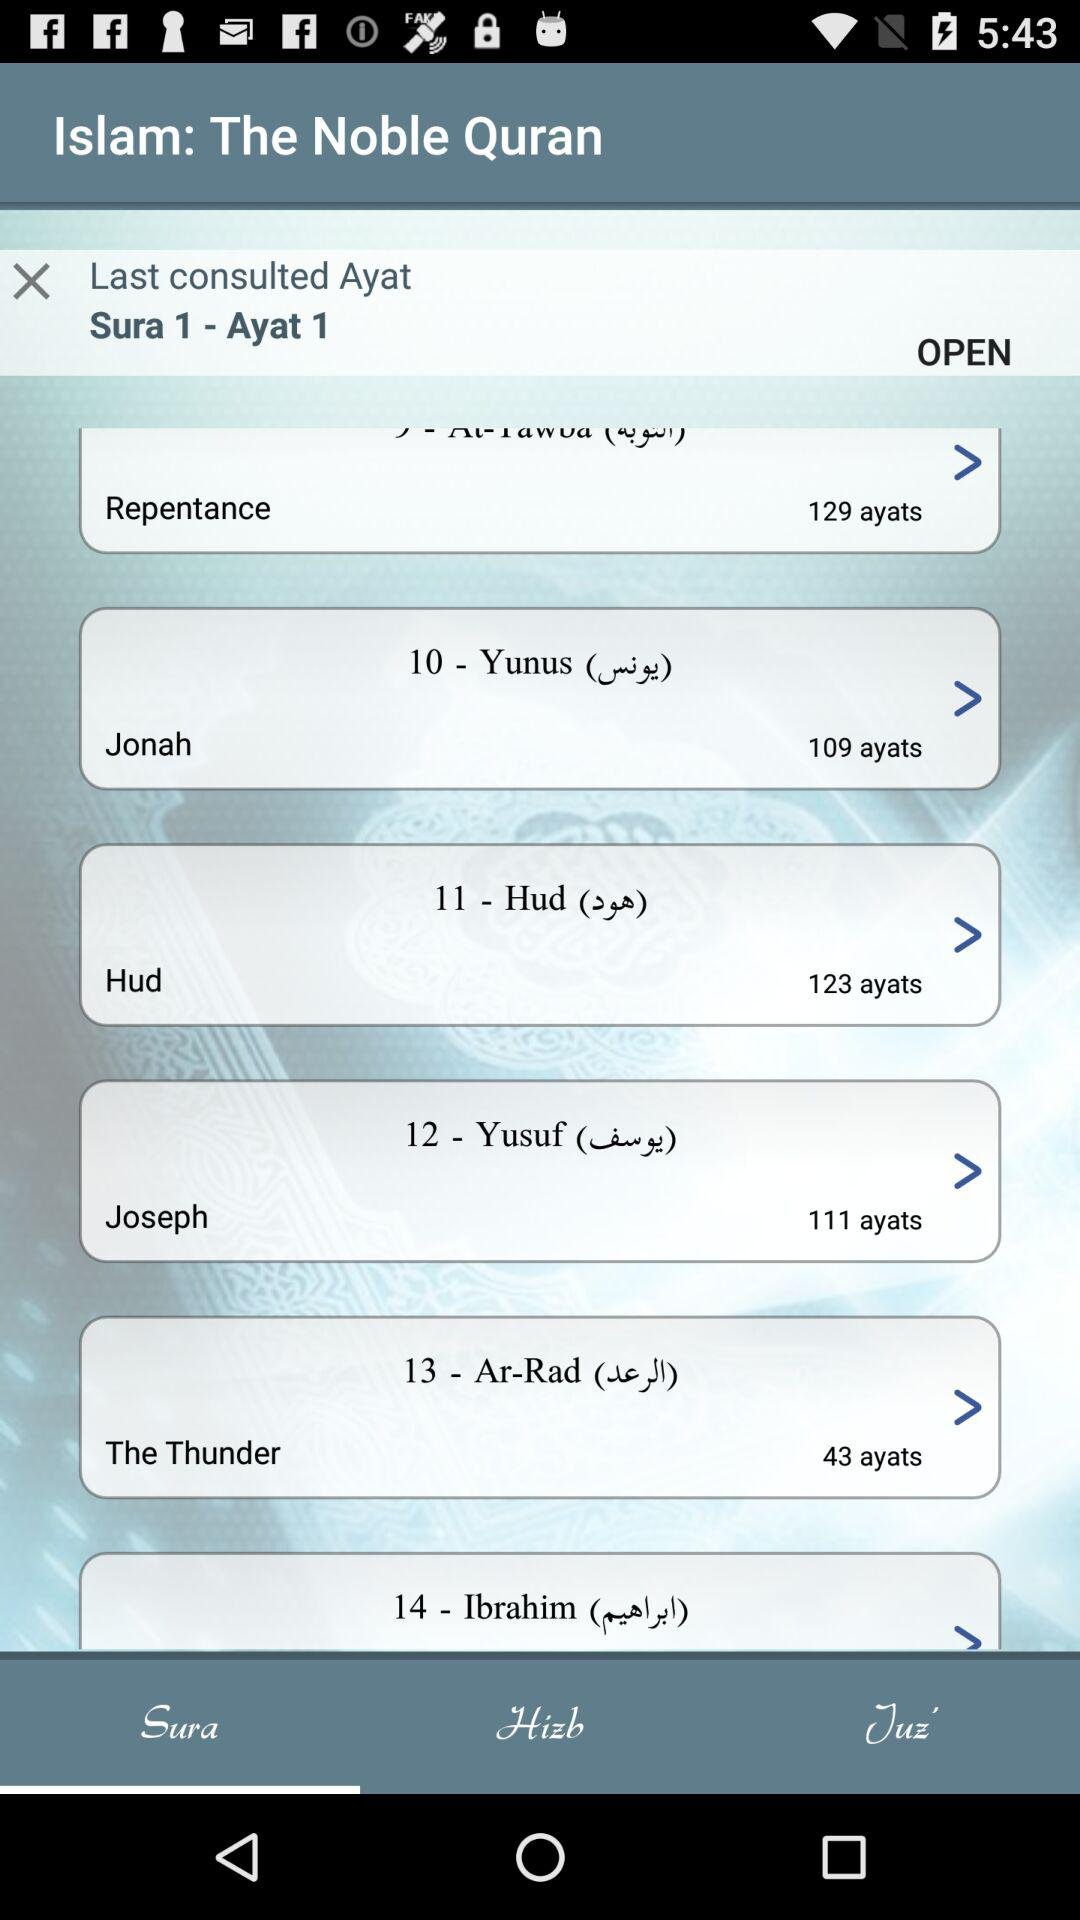What is the last consulted ayat? The last consulted ayat is "Sura 1 - Ayat 1". 